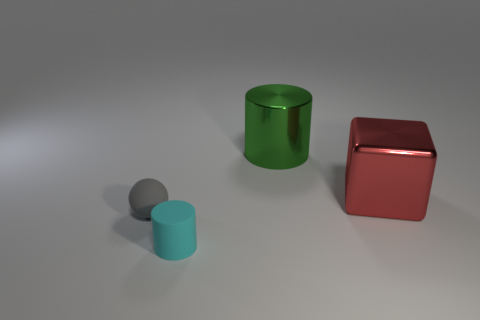Add 3 gray rubber things. How many objects exist? 7 Subtract all cubes. How many objects are left? 3 Subtract all brown blocks. How many green balls are left? 0 Subtract all gray shiny things. Subtract all tiny matte objects. How many objects are left? 2 Add 1 small cyan cylinders. How many small cyan cylinders are left? 2 Add 4 small gray metal balls. How many small gray metal balls exist? 4 Subtract 0 blue blocks. How many objects are left? 4 Subtract 1 cubes. How many cubes are left? 0 Subtract all cyan spheres. Subtract all green cylinders. How many spheres are left? 1 